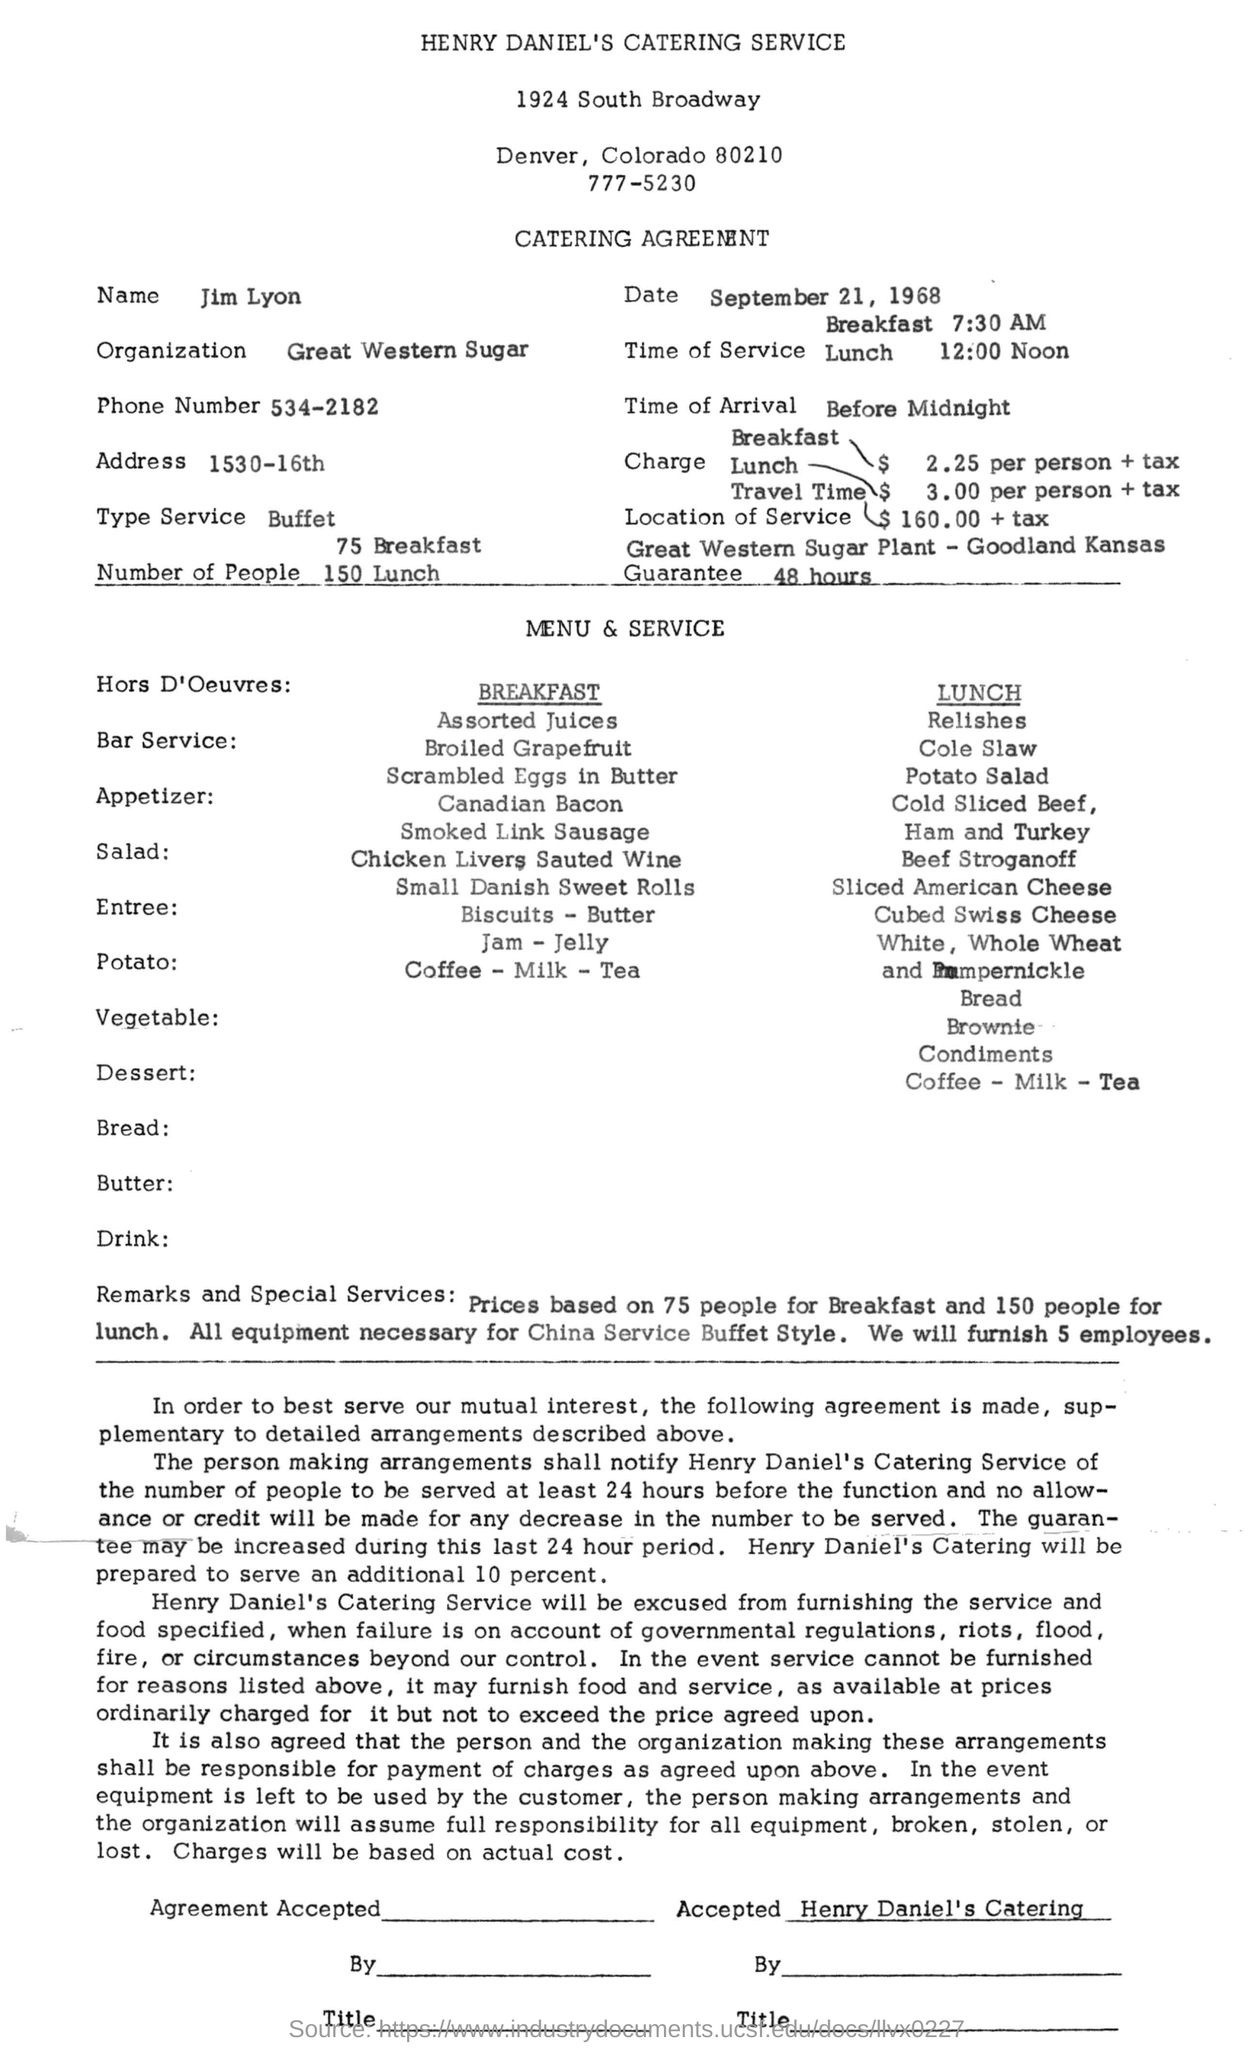What is name of the person given in the catering agreement?
Provide a short and direct response. Jim Lyon. What sort of agreement it is?
Give a very brief answer. CATERING. What is the name mentioned in this document?
Provide a succinct answer. Jim Lyon. What is date mentioned in the document
Make the answer very short. September 21, 1968. What is the name of Organisation
Keep it short and to the point. Great Western Sugar. What is the type of service?
Your answer should be very brief. Buffet. 